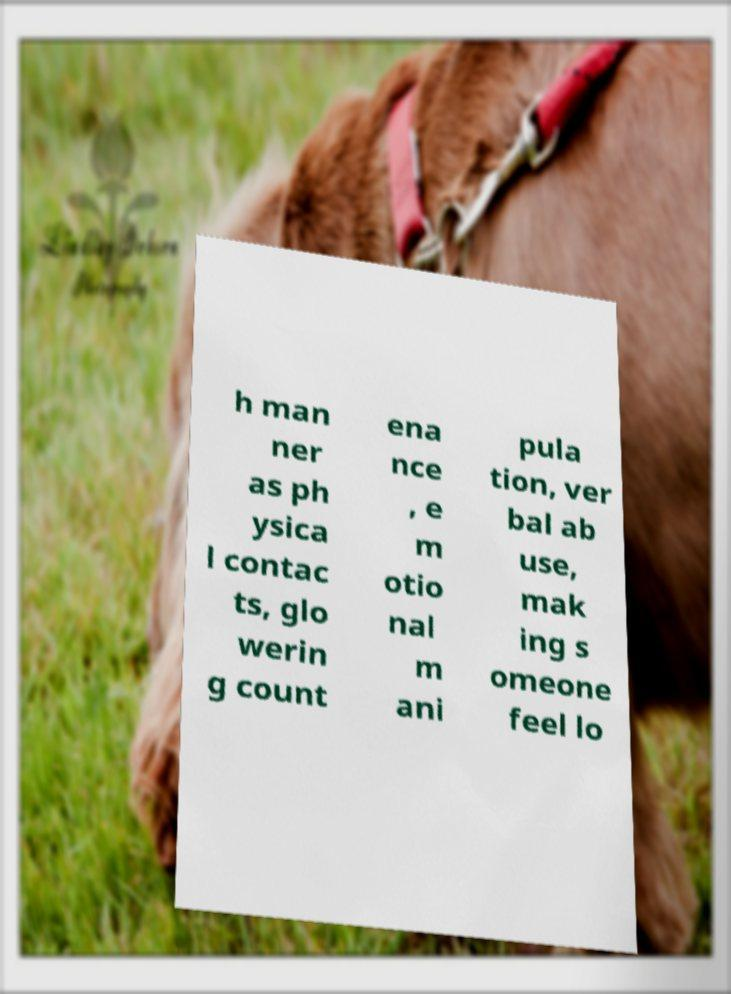I need the written content from this picture converted into text. Can you do that? h man ner as ph ysica l contac ts, glo werin g count ena nce , e m otio nal m ani pula tion, ver bal ab use, mak ing s omeone feel lo 